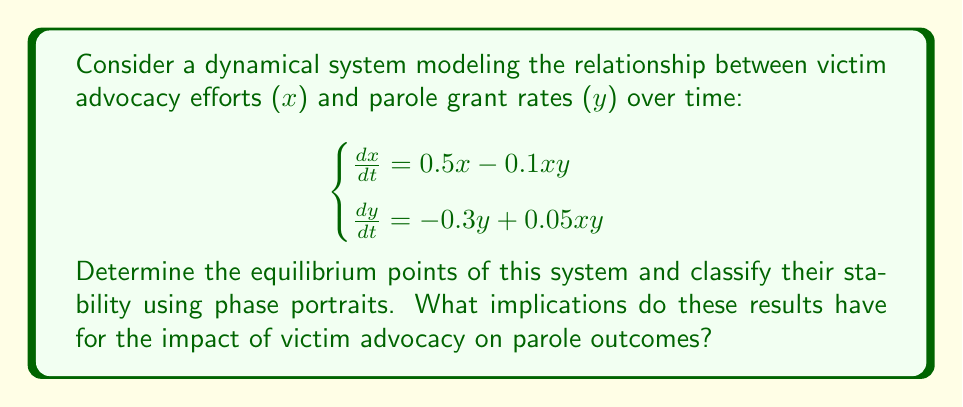Help me with this question. 1. Find the equilibrium points by setting $\frac{dx}{dt} = 0$ and $\frac{dy}{dt} = 0$:

   $0.5x - 0.1xy = 0$ and $-0.3y + 0.05xy = 0$

2. Solve the system:
   a) $(0, 0)$ is trivially an equilibrium point.
   b) For non-zero solutions:
      $0.5 - 0.1y = 0 \implies y = 5$
      $-0.3 + 0.05x = 0 \implies x = 6$
   
   So, the equilibrium points are $(0, 0)$ and $(6, 5)$.

3. To classify stability, we need to find the Jacobian matrix:

   $$J = \begin{bmatrix}
   0.5 - 0.1y & -0.1x \\
   0.05y & -0.3 + 0.05x
   \end{bmatrix}$$

4. Evaluate the Jacobian at $(0, 0)$:

   $$J_{(0,0)} = \begin{bmatrix}
   0.5 & 0 \\
   0 & -0.3
   \end{bmatrix}$$

   Eigenvalues: $\lambda_1 = 0.5$, $\lambda_2 = -0.3$
   This indicates a saddle point, which is unstable.

5. Evaluate the Jacobian at $(6, 5)$:

   $$J_{(6,5)} = \begin{bmatrix}
   0 & -0.6 \\
   0.25 & 0
   \end{bmatrix}$$

   Eigenvalues: $\lambda = \pm i\sqrt{0.15}$
   This indicates a center, which is neutrally stable.

6. The phase portrait would show:
   - Trajectories moving away from $(0, 0)$ in some directions and towards it in others.
   - Closed orbits around $(6, 5)$.

Implications:
- The unstable equilibrium at $(0, 0)$ suggests that a complete lack of victim advocacy and zero parole grants is not sustainable.
- The center at $(6, 5)$ implies a balanced state where victim advocacy efforts and parole grant rates oscillate around a fixed point, indicating a dynamic but stable relationship between advocacy and parole outcomes.
- The closed orbits around $(6, 5)$ suggest that the system will tend to maintain a cyclical pattern of advocacy efforts and parole rates, rather than converging to a fixed state.
Answer: Two equilibrium points: unstable saddle at $(0,0)$, neutrally stable center at $(6,5)$. Implies dynamic balance between advocacy and parole outcomes. 